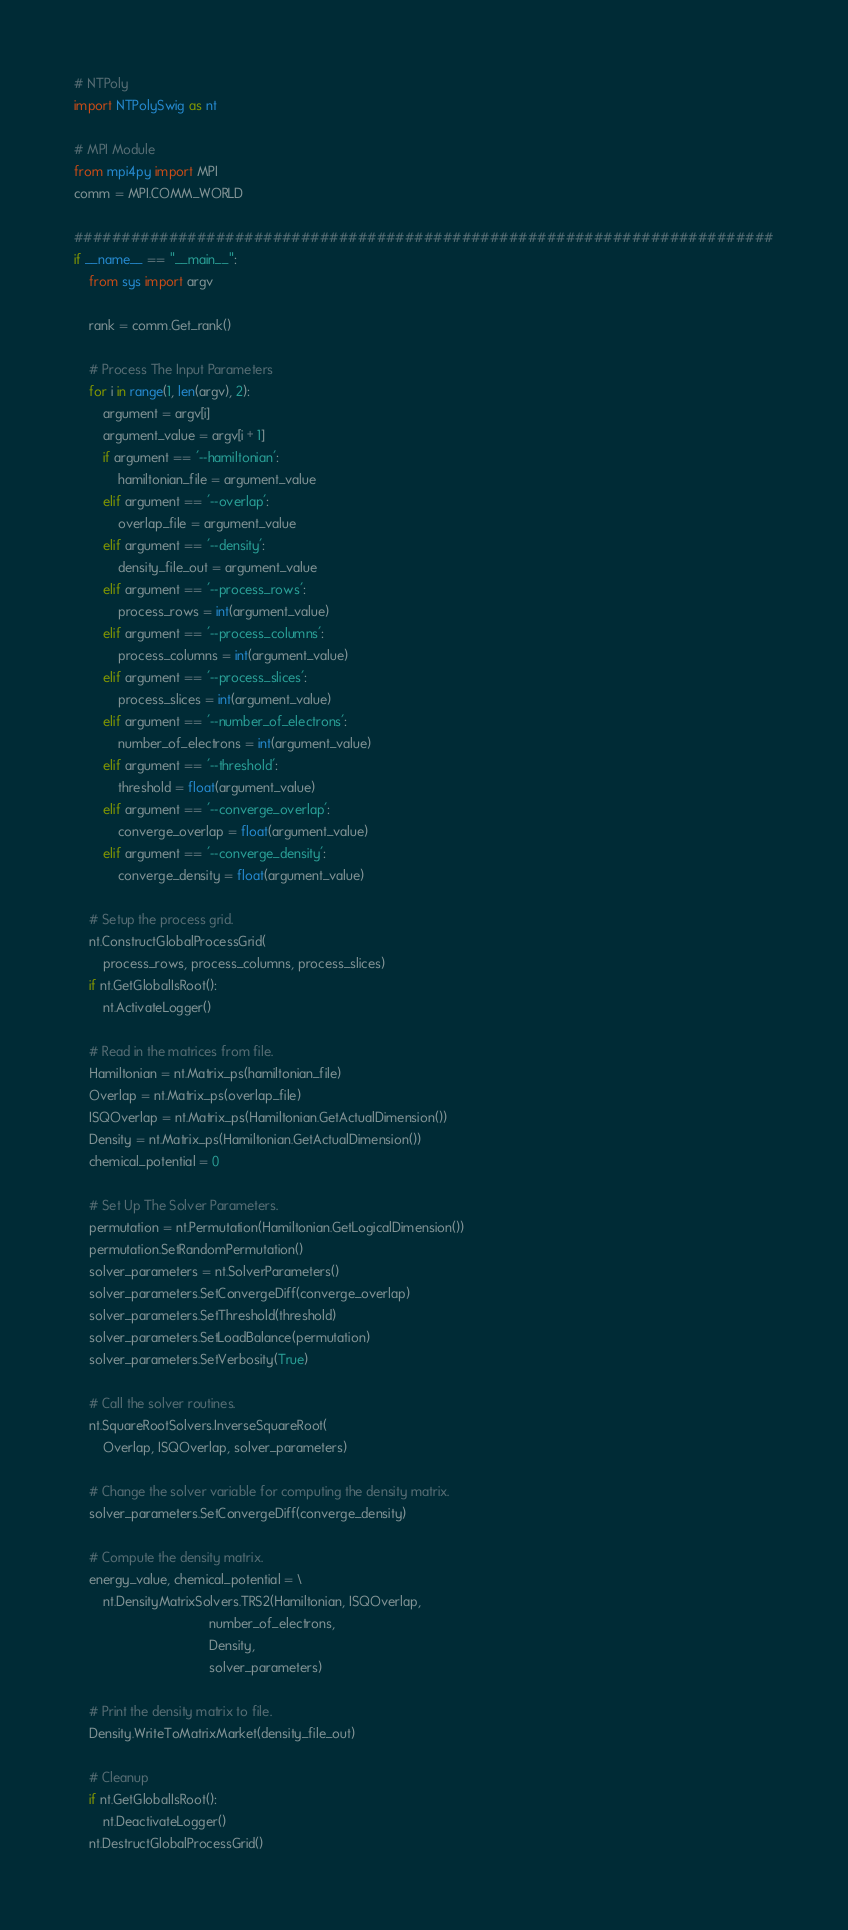<code> <loc_0><loc_0><loc_500><loc_500><_Python_># NTPoly
import NTPolySwig as nt

# MPI Module
from mpi4py import MPI
comm = MPI.COMM_WORLD

##########################################################################
if __name__ == "__main__":
    from sys import argv

    rank = comm.Get_rank()

    # Process The Input Parameters
    for i in range(1, len(argv), 2):
        argument = argv[i]
        argument_value = argv[i + 1]
        if argument == '--hamiltonian':
            hamiltonian_file = argument_value
        elif argument == '--overlap':
            overlap_file = argument_value
        elif argument == '--density':
            density_file_out = argument_value
        elif argument == '--process_rows':
            process_rows = int(argument_value)
        elif argument == '--process_columns':
            process_columns = int(argument_value)
        elif argument == '--process_slices':
            process_slices = int(argument_value)
        elif argument == '--number_of_electrons':
            number_of_electrons = int(argument_value)
        elif argument == '--threshold':
            threshold = float(argument_value)
        elif argument == '--converge_overlap':
            converge_overlap = float(argument_value)
        elif argument == '--converge_density':
            converge_density = float(argument_value)

    # Setup the process grid.
    nt.ConstructGlobalProcessGrid(
        process_rows, process_columns, process_slices)
    if nt.GetGlobalIsRoot():
        nt.ActivateLogger()

    # Read in the matrices from file.
    Hamiltonian = nt.Matrix_ps(hamiltonian_file)
    Overlap = nt.Matrix_ps(overlap_file)
    ISQOverlap = nt.Matrix_ps(Hamiltonian.GetActualDimension())
    Density = nt.Matrix_ps(Hamiltonian.GetActualDimension())
    chemical_potential = 0

    # Set Up The Solver Parameters.
    permutation = nt.Permutation(Hamiltonian.GetLogicalDimension())
    permutation.SetRandomPermutation()
    solver_parameters = nt.SolverParameters()
    solver_parameters.SetConvergeDiff(converge_overlap)
    solver_parameters.SetThreshold(threshold)
    solver_parameters.SetLoadBalance(permutation)
    solver_parameters.SetVerbosity(True)

    # Call the solver routines.
    nt.SquareRootSolvers.InverseSquareRoot(
        Overlap, ISQOverlap, solver_parameters)

    # Change the solver variable for computing the density matrix.
    solver_parameters.SetConvergeDiff(converge_density)

    # Compute the density matrix.
    energy_value, chemical_potential = \
        nt.DensityMatrixSolvers.TRS2(Hamiltonian, ISQOverlap,
                                     number_of_electrons,
                                     Density,
                                     solver_parameters)

    # Print the density matrix to file.
    Density.WriteToMatrixMarket(density_file_out)

    # Cleanup
    if nt.GetGlobalIsRoot():
        nt.DeactivateLogger()
    nt.DestructGlobalProcessGrid()
</code> 